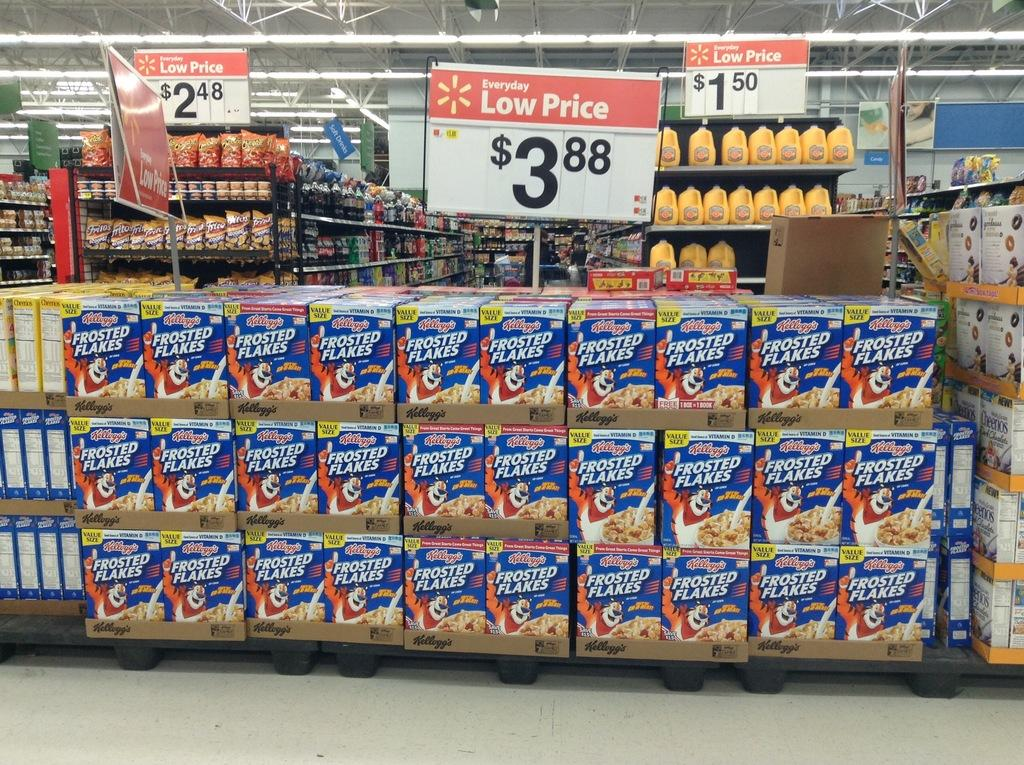<image>
Render a clear and concise summary of the photo. Boxes of frosted flake cereal is for sale for $3.88. 